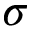Convert formula to latex. <formula><loc_0><loc_0><loc_500><loc_500>\sigma</formula> 